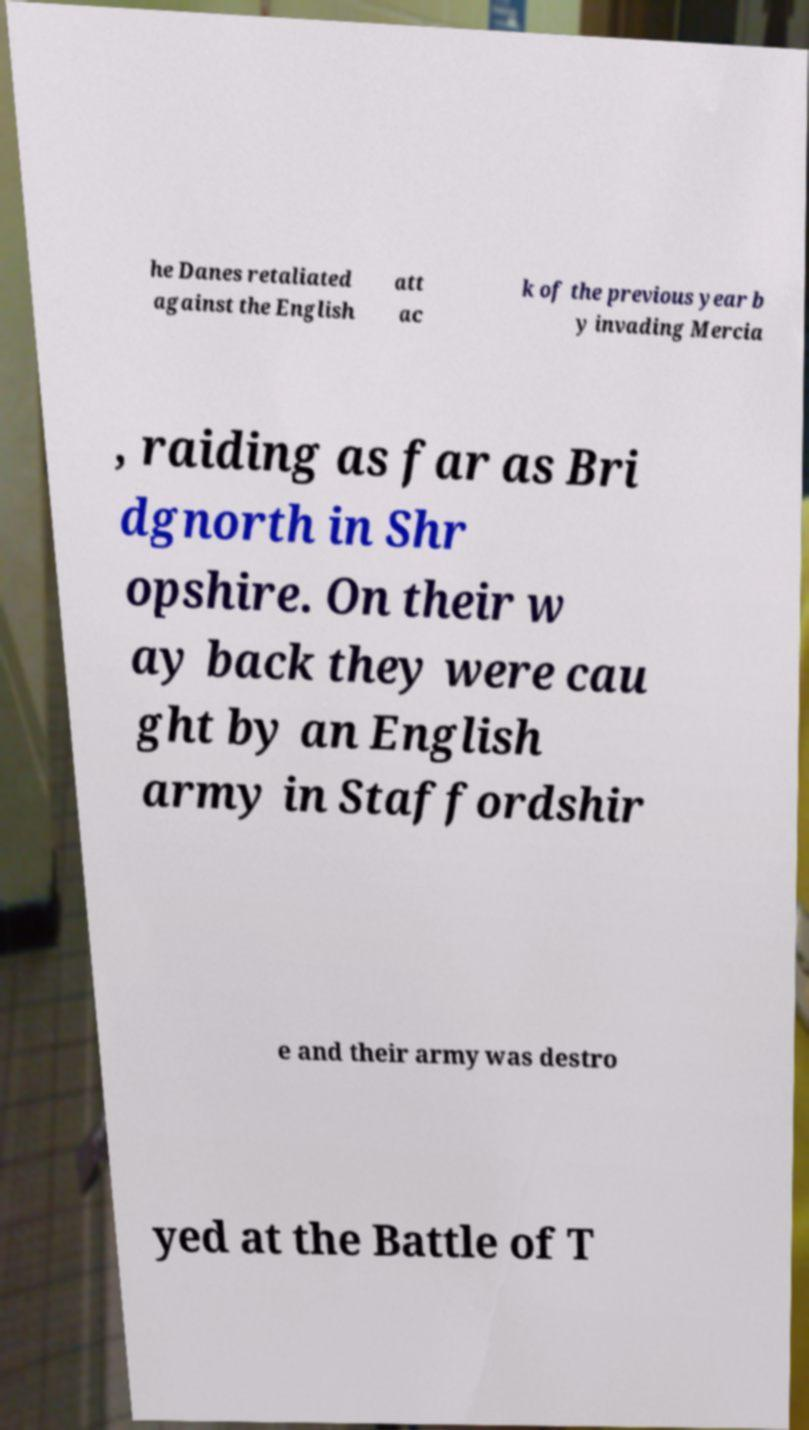Can you read and provide the text displayed in the image?This photo seems to have some interesting text. Can you extract and type it out for me? he Danes retaliated against the English att ac k of the previous year b y invading Mercia , raiding as far as Bri dgnorth in Shr opshire. On their w ay back they were cau ght by an English army in Staffordshir e and their army was destro yed at the Battle of T 